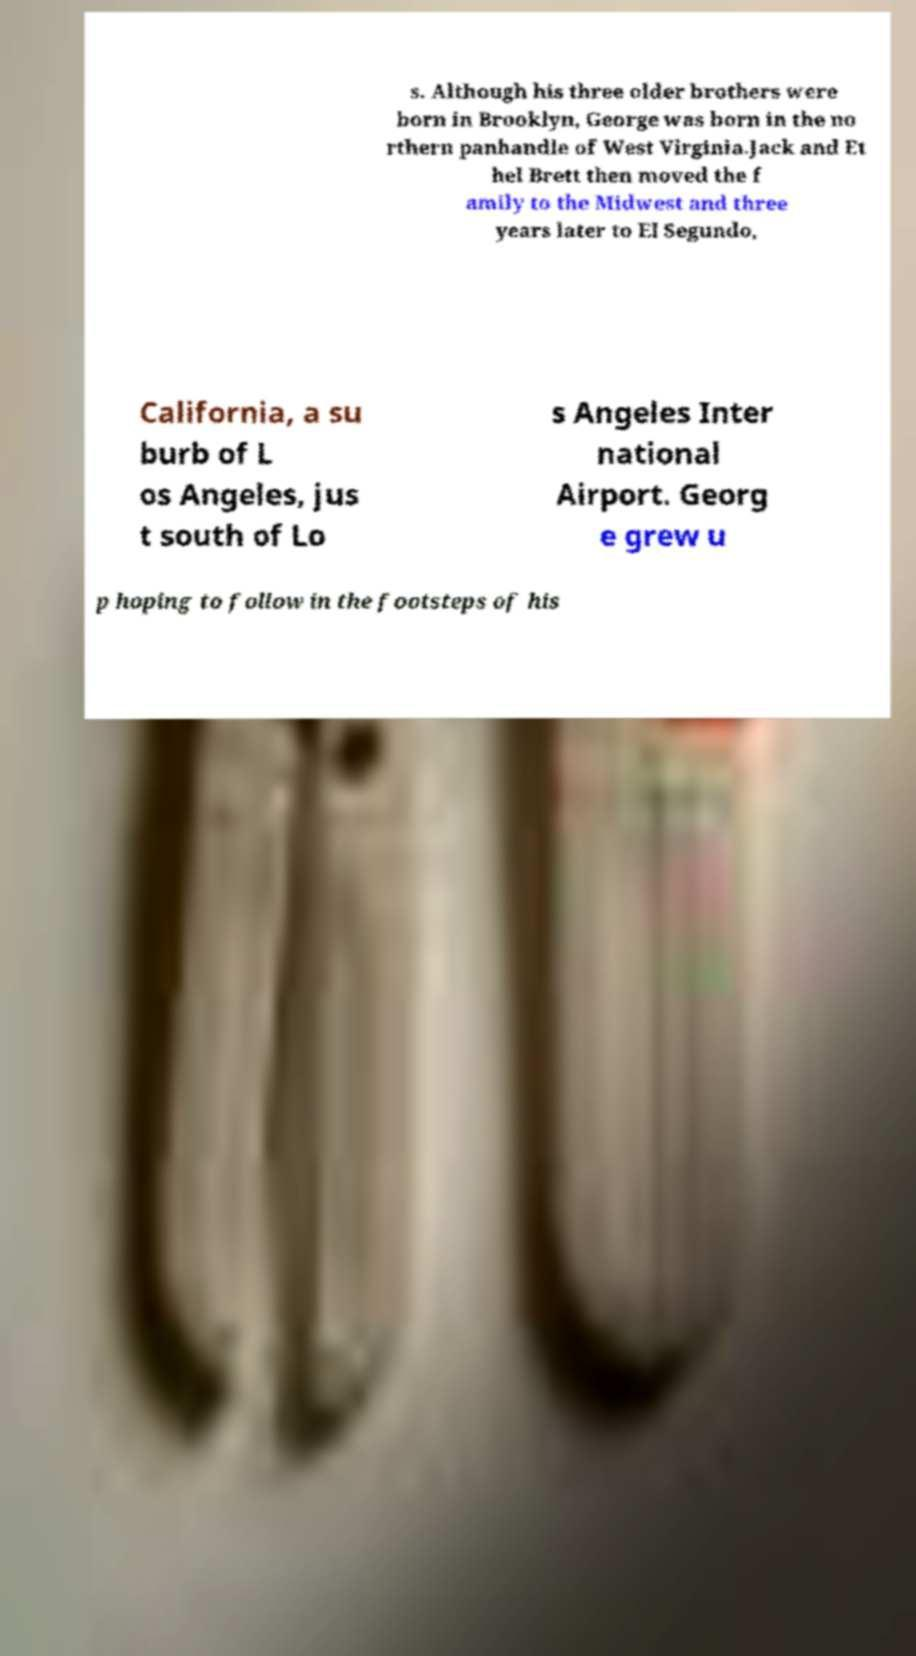Could you assist in decoding the text presented in this image and type it out clearly? s. Although his three older brothers were born in Brooklyn, George was born in the no rthern panhandle of West Virginia.Jack and Et hel Brett then moved the f amily to the Midwest and three years later to El Segundo, California, a su burb of L os Angeles, jus t south of Lo s Angeles Inter national Airport. Georg e grew u p hoping to follow in the footsteps of his 